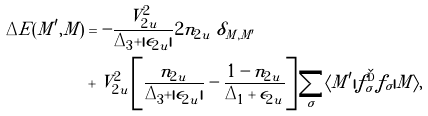Convert formula to latex. <formula><loc_0><loc_0><loc_500><loc_500>\Delta E ( M ^ { \prime } , M ) & = - \frac { V _ { 2 u } ^ { 2 } } { \Delta _ { 3 } + | \epsilon _ { 2 u } | } 2 n _ { 2 u } \ \delta _ { M , M ^ { \prime } } \\ & + V _ { 2 u } ^ { 2 } \left [ \frac { n _ { 2 u } } { \Delta _ { 3 } + | \epsilon _ { 2 u } | } - \frac { 1 - n _ { 2 u } } { \Delta _ { 1 } + \epsilon _ { 2 u } } \right ] \sum _ { \sigma } \langle M ^ { \prime } | f ^ { \dag } _ { \sigma } f _ { \sigma } | M \rangle ,</formula> 